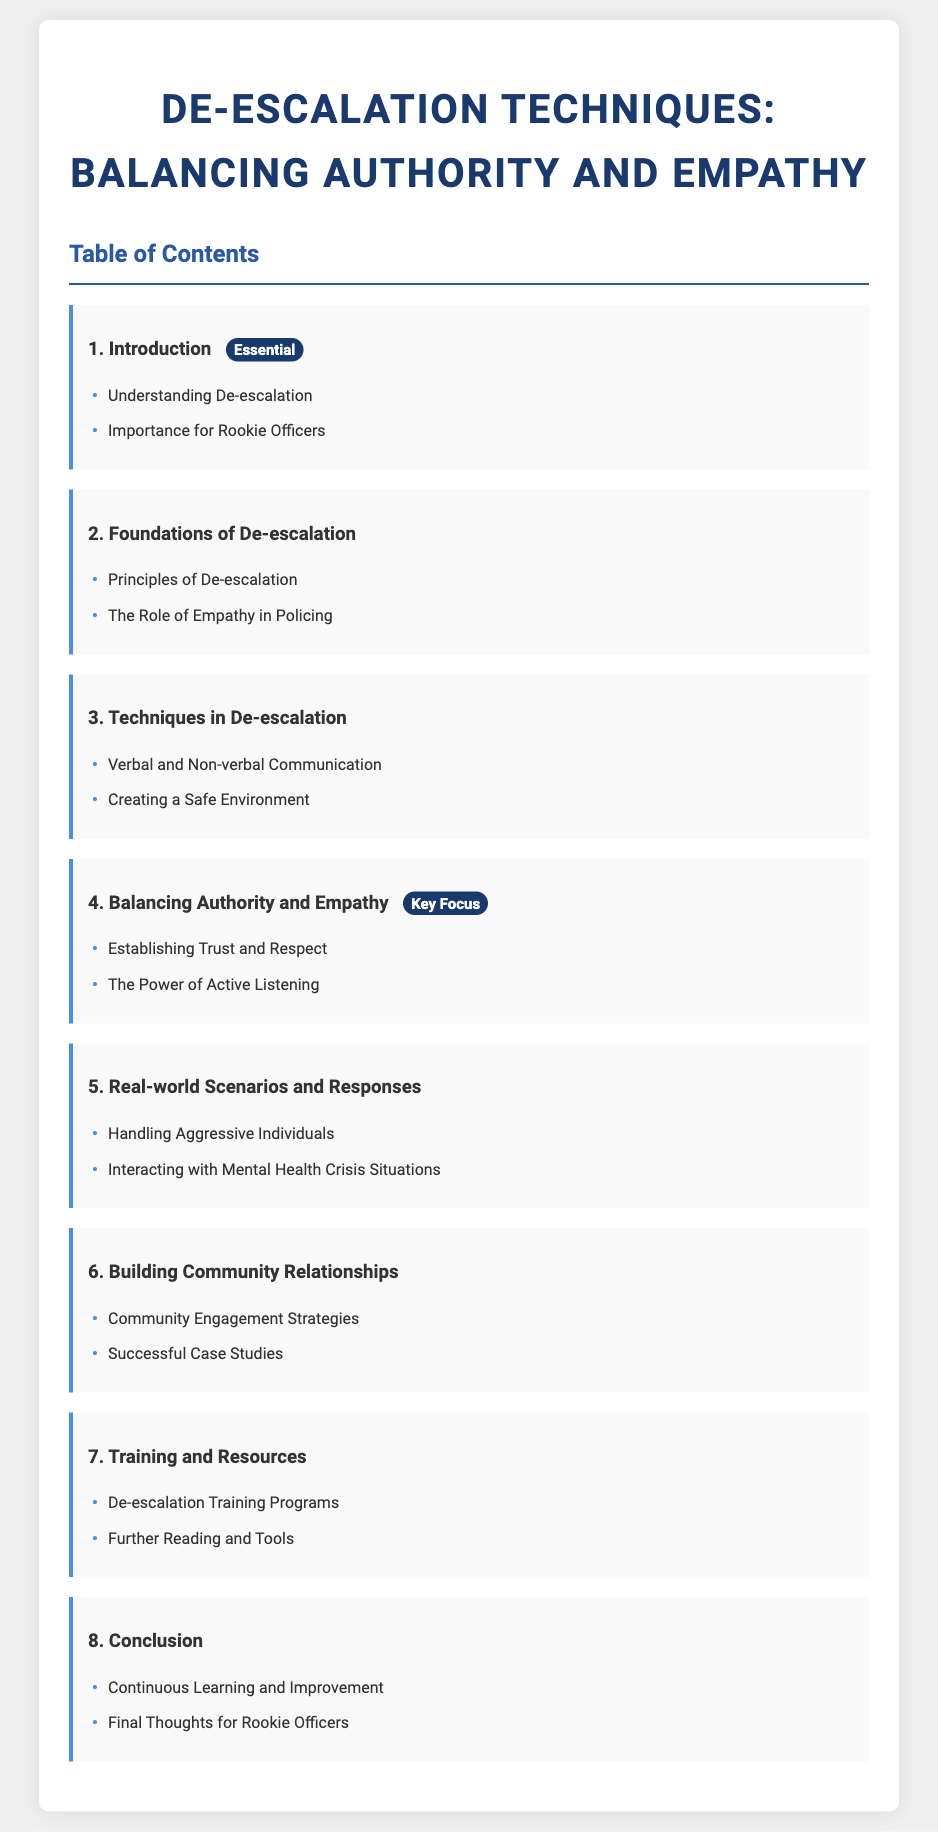What is the title of the document? The title of the document is presented prominently at the top, which is "De-escalation Techniques: Balancing Authority and Empathy."
Answer: De-escalation Techniques: Balancing Authority and Empathy How many sections are there in the Table of Contents? The document outlines a total of 8 sections in the Table of Contents.
Answer: 8 Which section focuses on balancing authority and empathy? The fourth section is specifically dedicated to this topic, indicated by its title.
Answer: Balancing Authority and Empathy What is a technique mentioned in the document for de-escalation? A specific technique for de-escalation is listed under the Techniques in De-escalation section, which includes communication methods.
Answer: Verbal and Non-verbal Communication What does the badge in section 4 indicate? The badge in section 4 highlights its significance and describes it as a key focus area within the document's framework.
Answer: Key Focus Which section discusses community engagement strategies? The section discussing strategies for engaging with the community can be found under the Building Community Relationships category.
Answer: Building Community Relationships What is emphasized at the end of the document? The conclusion section highlights the importance of ongoing development and reflection for officers.
Answer: Continuous Learning and Improvement What role does empathy play in policing according to the document? The document states the role of empathy is foundational to effective policing practices.
Answer: The Role of Empathy in Policing 